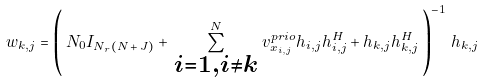<formula> <loc_0><loc_0><loc_500><loc_500>w _ { k , j } = \left ( \, N _ { 0 } I _ { N _ { r } ( N \, + \, J ) } + \, \sum _ { \substack { i = 1 , i \neq k } } ^ { N } \, v _ { x _ { i , j } } ^ { p r i o } h _ { i , j } h _ { i , j } ^ { H } + h _ { k , j } h _ { k , j } ^ { H } \, \right ) ^ { - 1 } \, h _ { k , j }</formula> 